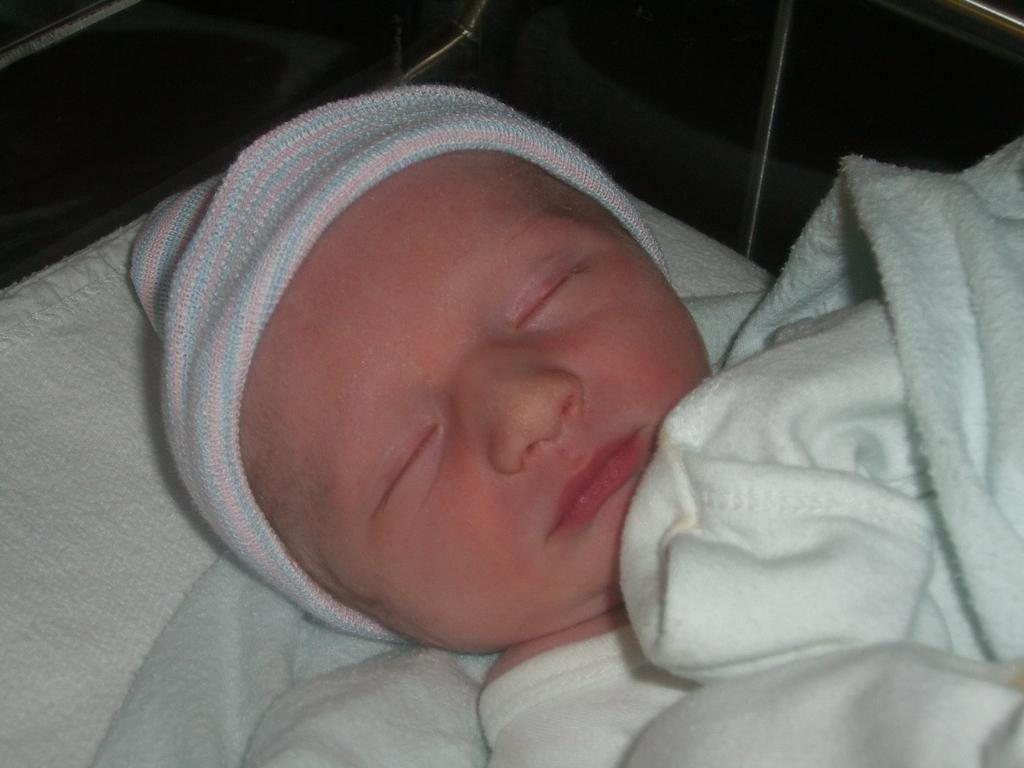What is the main subject of the image? The main subject of the image is a kid. How is the kid covered in the image? The kid is covered by a white color blanket. Can you describe the background of the image? The background of the image has both white and black colors. What type of teeth can be seen in the image? There are no teeth visible in the image, as it features a kid covered by a white color blanket with a background of white and black colors. 